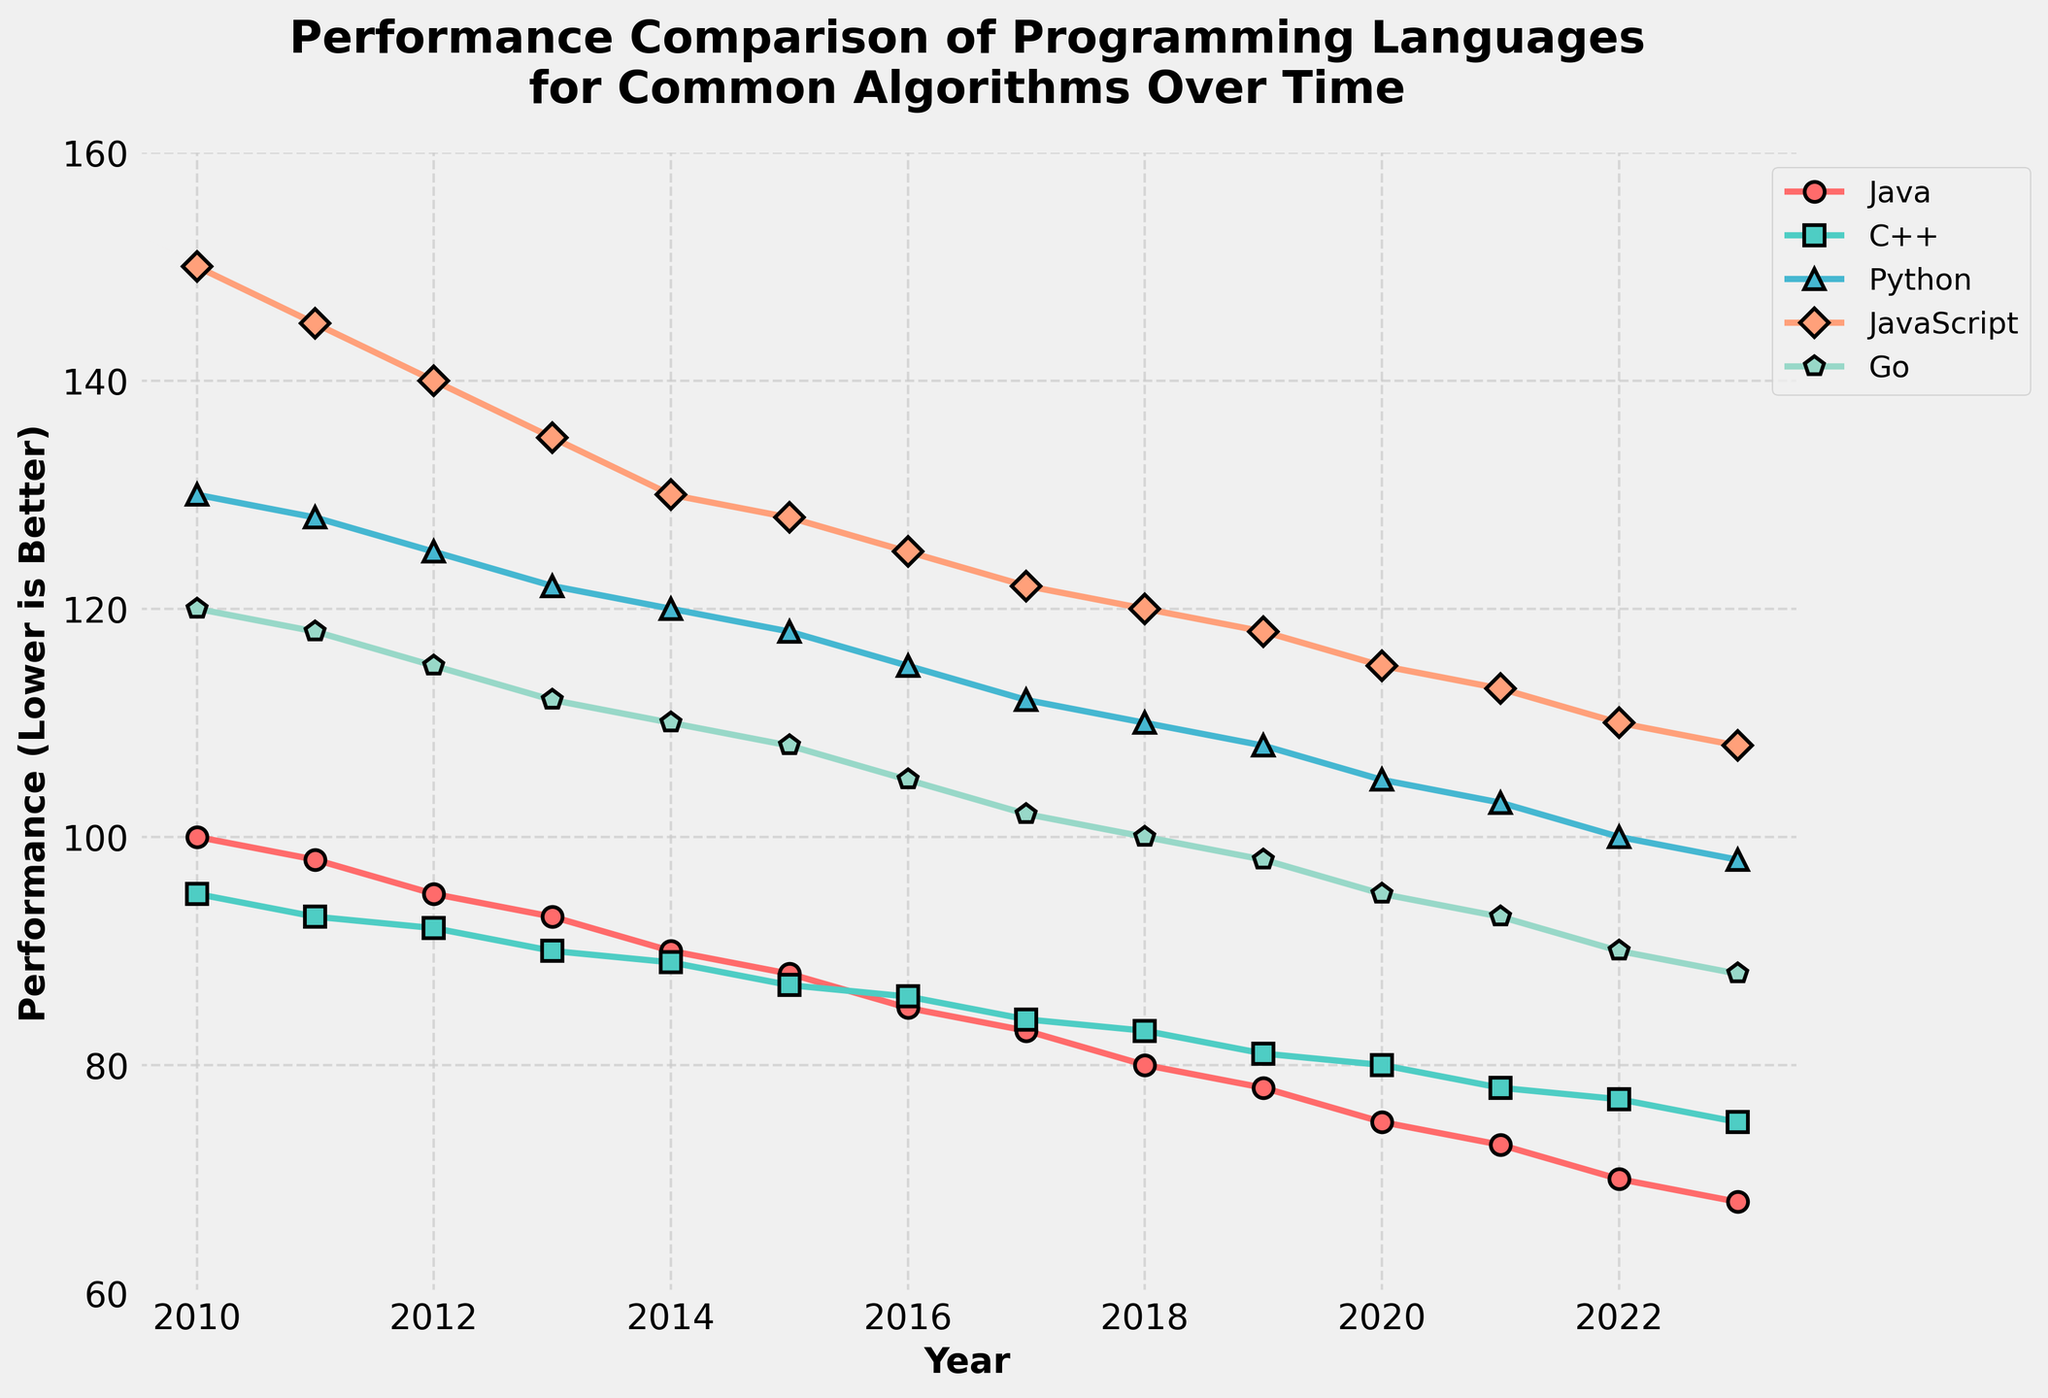What year did Java have the lowest performance? Identify the value in the Java series that is the smallest and find the corresponding year. The lowest value for Java is 68, which occurs in 2023.
Answer: 2023 Between 2010 and 2023, in which year did Python's performance first drop below 110? Track Python's performance from 2010 onwards, and find the first year where it crosses the 110 threshold. Python’s performance dropped below 110 in 2018.
Answer: 2018 Which programming language had the highest performance in 2015? Compare the values of Java, C++, Python, JavaScript, and Go in 2015 to find the highest value. JavaScript had the highest performance in 2015 with a value of 128.
Answer: JavaScript How much did Java's performance change from 2010 to 2023? Subtract Java's performance value in 2023 from the value in 2010 to find the change: 100 (2010) - 68 (2023) = 32.
Answer: 32 In which years did Go's performance equal 100? Look for the values of 100 in the Go series and list the corresponding years. Go's performance equaled 100 in 2018.
Answer: 2018 Which language showed the most consistent performance trend from 2010 to 2023? Analyze the trends of all five languages, checking for the least variation and most consistent decrease in values. Java shows the most consistent decreasing trend.
Answer: Java How does the performance of Python in 2023 compare to its performance in 2010 and 2015? Compare Python's values: 130 (2010), 118 (2015), and 98 (2023). Python's performance consistently decreased over these years.
Answer: Decreased What is the average performance of C++ from 2010 to 2023? Calculate the average by summing up C++ values from 2010 to 2023 and dividing by the number of years (14): (95 + 93 + 92 + 90 + 89 + 87 + 86 + 84 + 83 + 81 + 80 + 78 + 77 + 75) / 14 = 84.1.
Answer: 84.1 Which language had the greatest performance drop between 2010 and 2023? Calculate the difference for each language between 2010 and 2023 and find the largest drop. JavaScript dropped from 150 to 108, a drop of 42.
Answer: JavaScript How does the performance trend of C++ compare to that of Go? Observe the trend lines for both C++ and Go; both show a general decrease, but Go remains consistently higher than C++ throughout the years. Go shows a similar decreasing trend but with better performance overall.
Answer: Similar but Go is better 